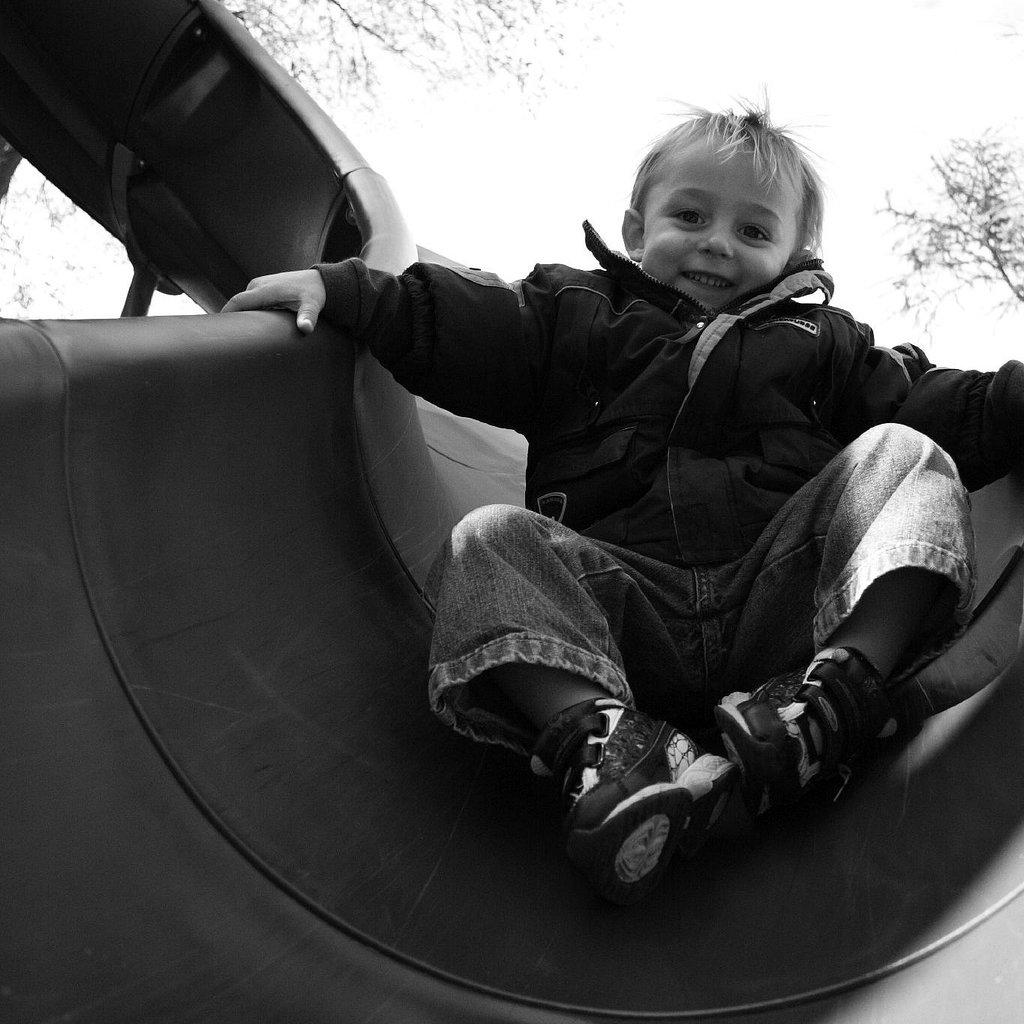What is the color scheme of the image? The image is black and white. Who is the main subject in the image? There is a boy in the image. What is the boy doing in the image? The boy is sliding down from a slide. What type of unit is the boy using to measure the distance he slides in the image? There is no unit present in the image, and the boy is not measuring any distance. 